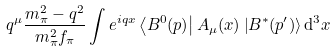Convert formula to latex. <formula><loc_0><loc_0><loc_500><loc_500>q ^ { \mu } \frac { m _ { \pi } ^ { 2 } - q ^ { 2 } } { m _ { \pi } ^ { 2 } f _ { \pi } } \int e ^ { i q x } \left \langle B ^ { 0 } ( p ) \right | A _ { \mu } ( x ) \left | B ^ { * } ( p ^ { \prime } ) \right \rangle { \mathrm d } ^ { 3 } x</formula> 